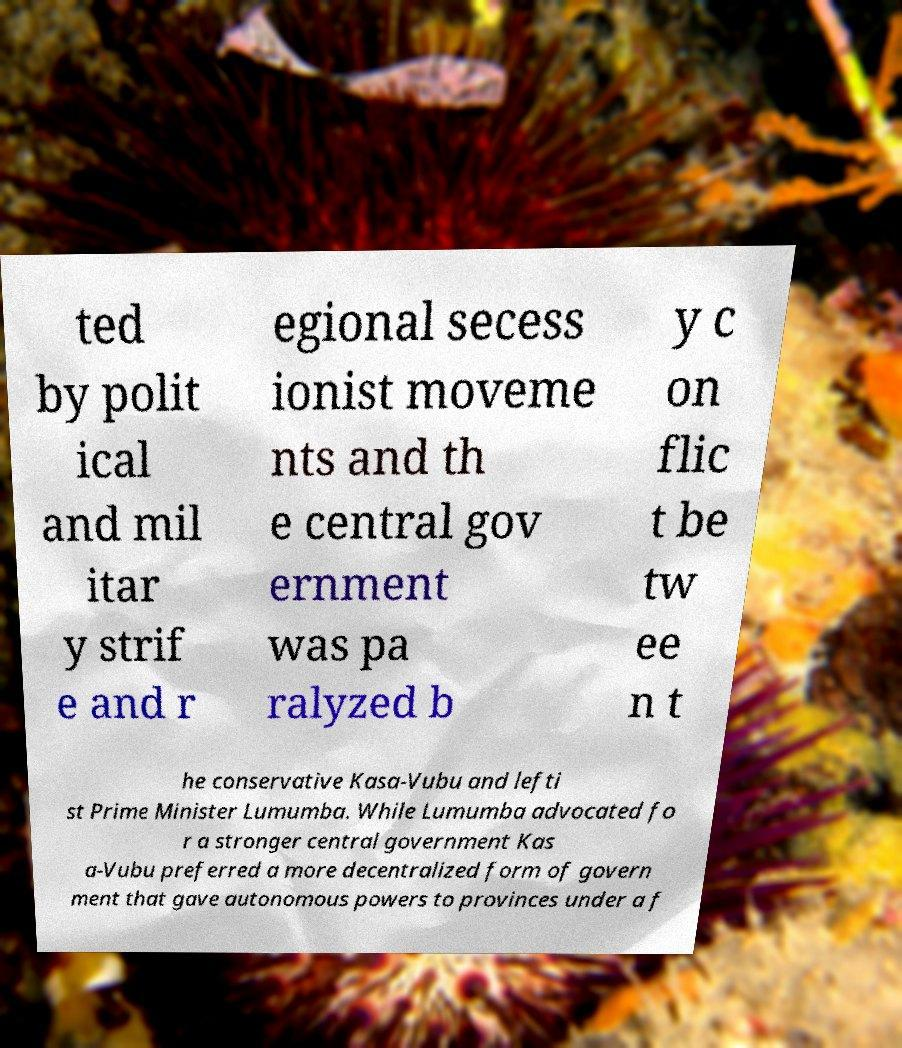Please identify and transcribe the text found in this image. ted by polit ical and mil itar y strif e and r egional secess ionist moveme nts and th e central gov ernment was pa ralyzed b y c on flic t be tw ee n t he conservative Kasa-Vubu and lefti st Prime Minister Lumumba. While Lumumba advocated fo r a stronger central government Kas a-Vubu preferred a more decentralized form of govern ment that gave autonomous powers to provinces under a f 